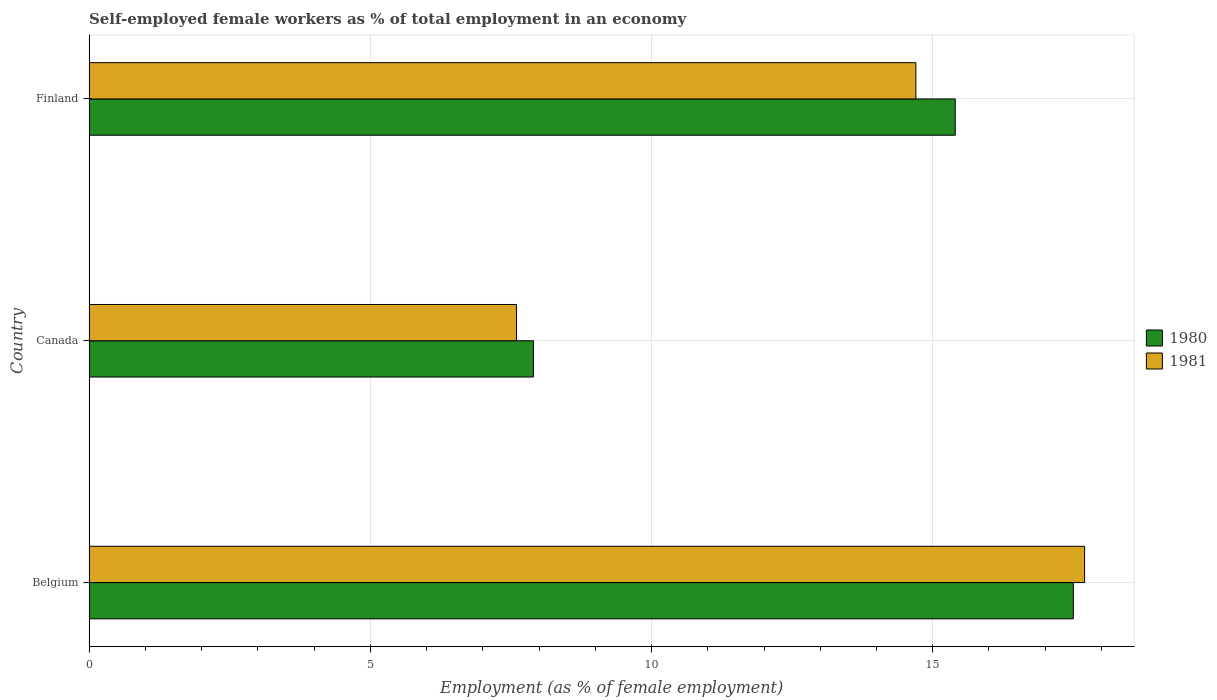Are the number of bars per tick equal to the number of legend labels?
Your answer should be compact. Yes. Are the number of bars on each tick of the Y-axis equal?
Make the answer very short. Yes. How many bars are there on the 3rd tick from the bottom?
Your response must be concise. 2. What is the label of the 3rd group of bars from the top?
Give a very brief answer. Belgium. What is the percentage of self-employed female workers in 1981 in Finland?
Make the answer very short. 14.7. Across all countries, what is the maximum percentage of self-employed female workers in 1980?
Your response must be concise. 17.5. Across all countries, what is the minimum percentage of self-employed female workers in 1981?
Make the answer very short. 7.6. In which country was the percentage of self-employed female workers in 1980 maximum?
Offer a terse response. Belgium. In which country was the percentage of self-employed female workers in 1981 minimum?
Provide a short and direct response. Canada. What is the total percentage of self-employed female workers in 1980 in the graph?
Keep it short and to the point. 40.8. What is the difference between the percentage of self-employed female workers in 1980 in Belgium and that in Finland?
Provide a short and direct response. 2.1. What is the difference between the percentage of self-employed female workers in 1980 in Finland and the percentage of self-employed female workers in 1981 in Canada?
Ensure brevity in your answer.  7.8. What is the average percentage of self-employed female workers in 1981 per country?
Provide a succinct answer. 13.33. What is the difference between the percentage of self-employed female workers in 1981 and percentage of self-employed female workers in 1980 in Canada?
Your answer should be very brief. -0.3. In how many countries, is the percentage of self-employed female workers in 1980 greater than 16 %?
Your answer should be very brief. 1. What is the ratio of the percentage of self-employed female workers in 1981 in Belgium to that in Finland?
Offer a very short reply. 1.2. What is the difference between the highest and the second highest percentage of self-employed female workers in 1980?
Give a very brief answer. 2.1. What is the difference between the highest and the lowest percentage of self-employed female workers in 1980?
Offer a very short reply. 9.6. What does the 1st bar from the bottom in Finland represents?
Make the answer very short. 1980. How many bars are there?
Provide a succinct answer. 6. Are all the bars in the graph horizontal?
Provide a short and direct response. Yes. How many countries are there in the graph?
Offer a very short reply. 3. Are the values on the major ticks of X-axis written in scientific E-notation?
Keep it short and to the point. No. Does the graph contain any zero values?
Offer a very short reply. No. Where does the legend appear in the graph?
Your response must be concise. Center right. How are the legend labels stacked?
Your response must be concise. Vertical. What is the title of the graph?
Your answer should be compact. Self-employed female workers as % of total employment in an economy. Does "1964" appear as one of the legend labels in the graph?
Give a very brief answer. No. What is the label or title of the X-axis?
Your answer should be very brief. Employment (as % of female employment). What is the label or title of the Y-axis?
Offer a very short reply. Country. What is the Employment (as % of female employment) of 1981 in Belgium?
Your answer should be compact. 17.7. What is the Employment (as % of female employment) of 1980 in Canada?
Keep it short and to the point. 7.9. What is the Employment (as % of female employment) in 1981 in Canada?
Give a very brief answer. 7.6. What is the Employment (as % of female employment) of 1980 in Finland?
Provide a short and direct response. 15.4. What is the Employment (as % of female employment) in 1981 in Finland?
Ensure brevity in your answer.  14.7. Across all countries, what is the maximum Employment (as % of female employment) in 1980?
Make the answer very short. 17.5. Across all countries, what is the maximum Employment (as % of female employment) in 1981?
Make the answer very short. 17.7. Across all countries, what is the minimum Employment (as % of female employment) of 1980?
Provide a short and direct response. 7.9. Across all countries, what is the minimum Employment (as % of female employment) of 1981?
Offer a very short reply. 7.6. What is the total Employment (as % of female employment) in 1980 in the graph?
Keep it short and to the point. 40.8. What is the difference between the Employment (as % of female employment) of 1980 in Belgium and that in Canada?
Offer a very short reply. 9.6. What is the difference between the Employment (as % of female employment) of 1980 in Belgium and that in Finland?
Keep it short and to the point. 2.1. What is the difference between the Employment (as % of female employment) in 1980 in Canada and that in Finland?
Your answer should be very brief. -7.5. What is the difference between the Employment (as % of female employment) of 1980 in Canada and the Employment (as % of female employment) of 1981 in Finland?
Ensure brevity in your answer.  -6.8. What is the average Employment (as % of female employment) of 1980 per country?
Offer a terse response. 13.6. What is the average Employment (as % of female employment) in 1981 per country?
Give a very brief answer. 13.33. What is the difference between the Employment (as % of female employment) of 1980 and Employment (as % of female employment) of 1981 in Finland?
Make the answer very short. 0.7. What is the ratio of the Employment (as % of female employment) in 1980 in Belgium to that in Canada?
Your answer should be very brief. 2.22. What is the ratio of the Employment (as % of female employment) in 1981 in Belgium to that in Canada?
Provide a short and direct response. 2.33. What is the ratio of the Employment (as % of female employment) in 1980 in Belgium to that in Finland?
Keep it short and to the point. 1.14. What is the ratio of the Employment (as % of female employment) of 1981 in Belgium to that in Finland?
Your answer should be compact. 1.2. What is the ratio of the Employment (as % of female employment) of 1980 in Canada to that in Finland?
Provide a short and direct response. 0.51. What is the ratio of the Employment (as % of female employment) of 1981 in Canada to that in Finland?
Your response must be concise. 0.52. What is the difference between the highest and the lowest Employment (as % of female employment) in 1980?
Offer a terse response. 9.6. 